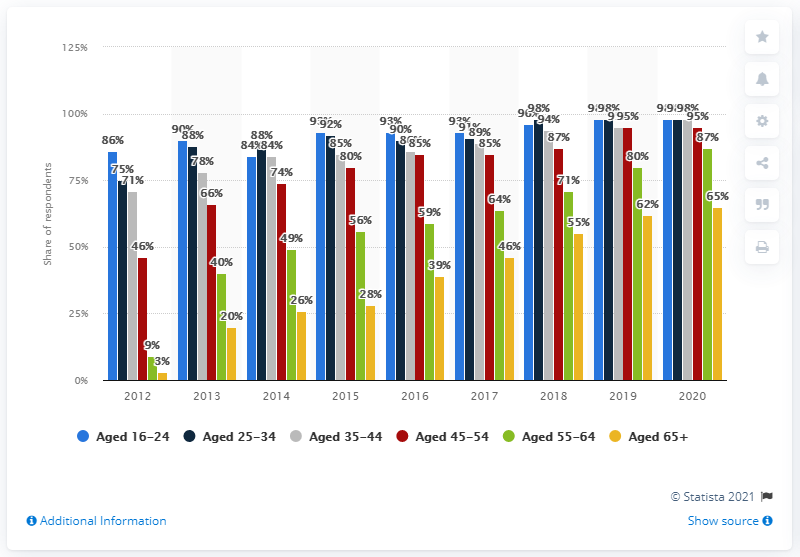Identify some key points in this picture. In 2012, approximately 9% of individuals aged 55-64 used a smartphone. By 2020, it is projected that 87% of 55-64 year olds will use a smartphone. Since 2012, smartphone usage has increased among individuals of all age groups. 